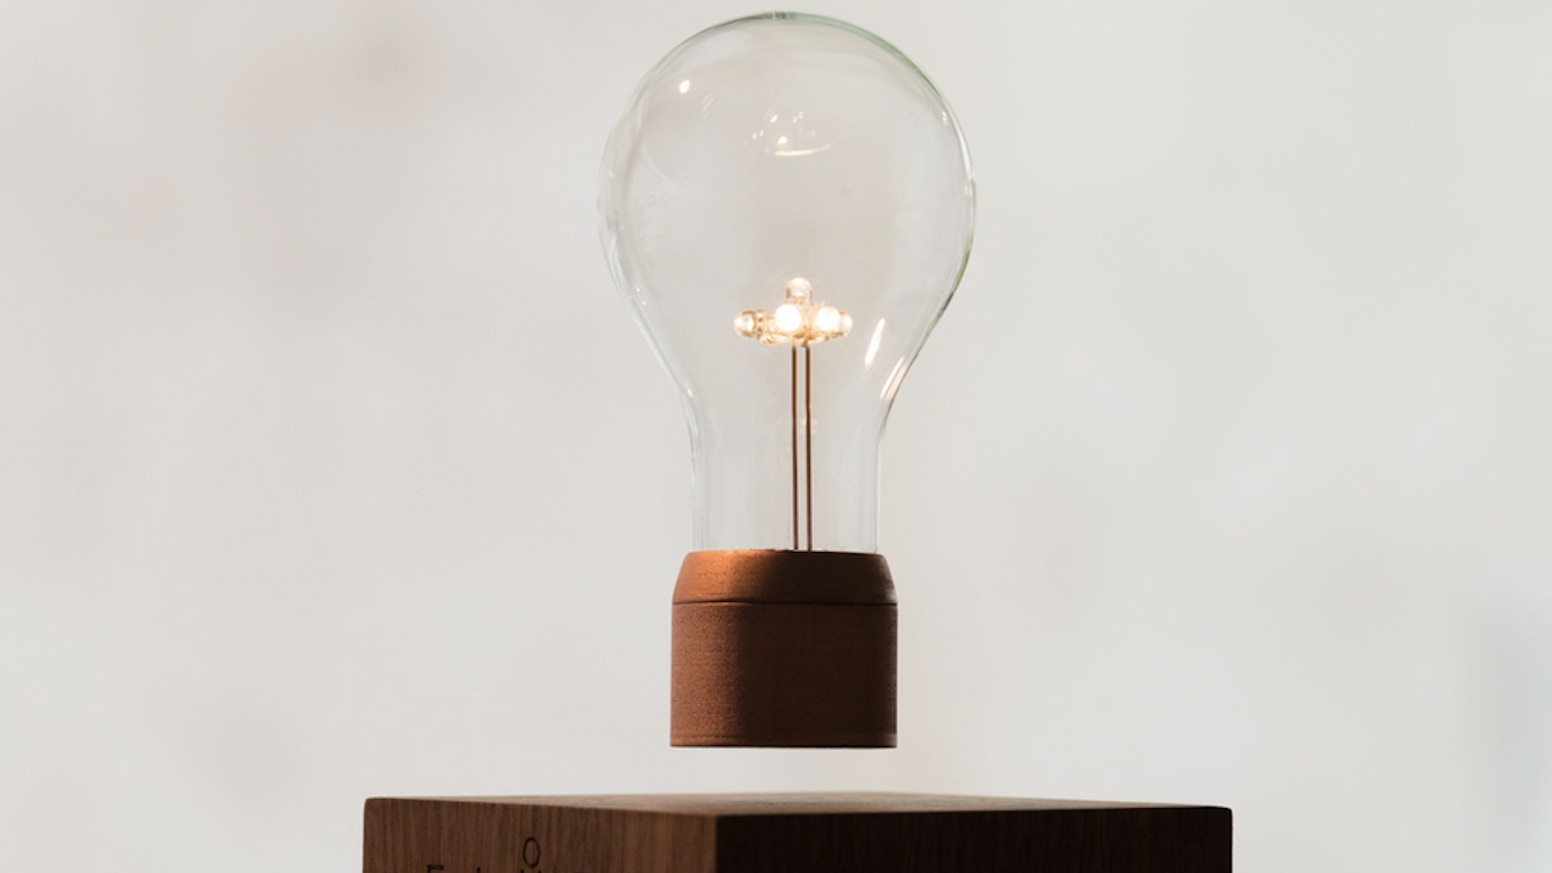How does the design of this light bulb affect its overall efficiency? The design of the light bulb, with its multiple filament arms, typically does not prioritize efficiency as much as aesthetic value. Traditional multi-filament bulbs, like the one shown, usually consume more energy than single filament designs and are less efficient than LED bulbs. The complex filament design provides a beautiful, warm light but is not ideal for energy conservation. 